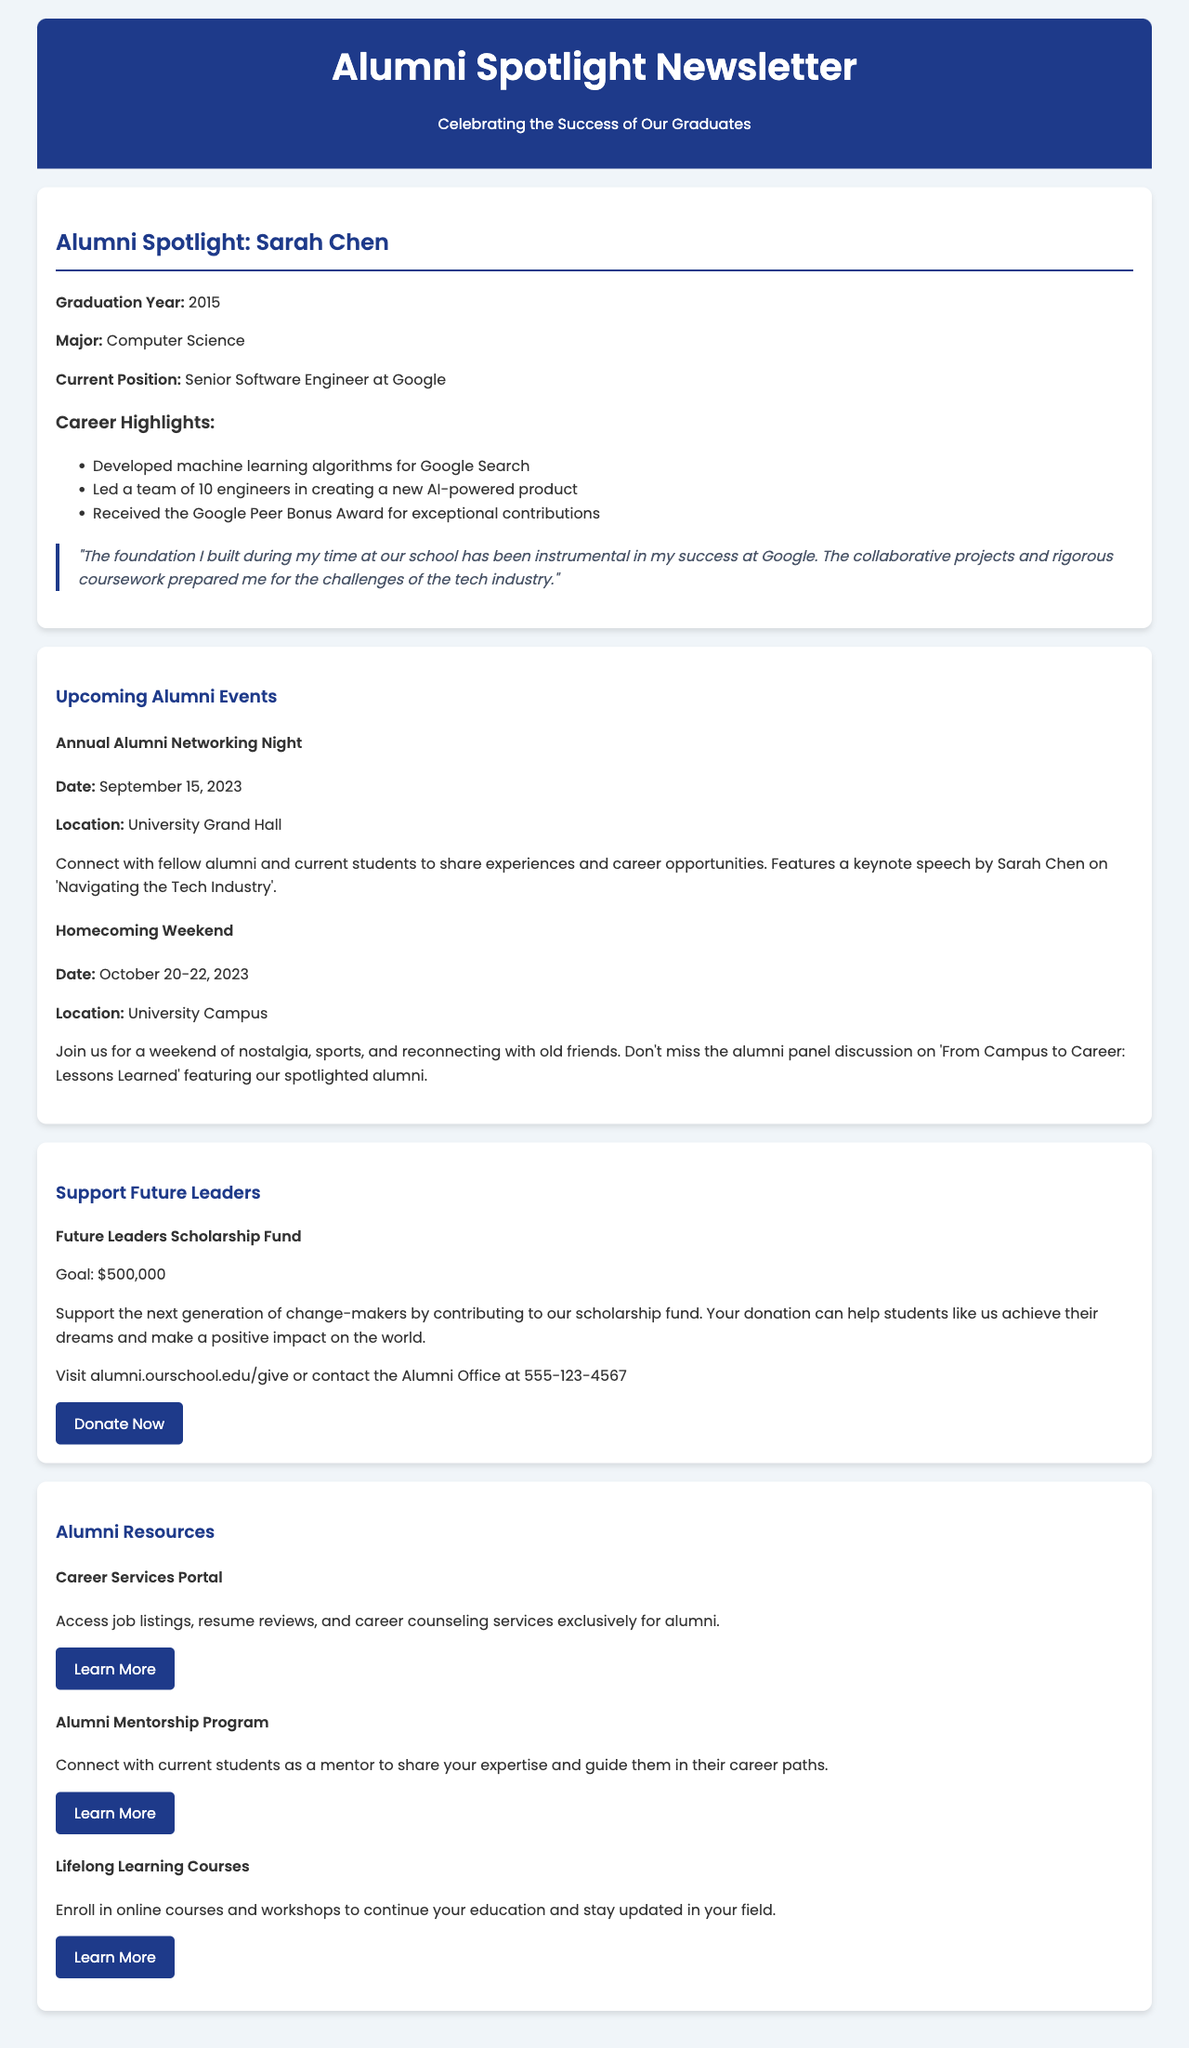What is Sarah Chen's current position? The document explicitly states that Sarah Chen is a Senior Software Engineer at Google.
Answer: Senior Software Engineer at Google What year did Michael Rodriguez graduate? According to the document, Michael Rodriguez graduated in 2012.
Answer: 2012 How much funding did GreenTech Solutions raise? The document mentions that GreenTech Solutions raised $10 million in Series A funding.
Answer: $10 million What is the date of the Annual Alumni Networking Night? The document provides the date as September 15, 2023, for the Annual Alumni Networking Night.
Answer: September 15, 2023 What is the goal amount for the Future Leaders Scholarship Fund? The document indicates that the goal amount for the scholarship fund is $500,000.
Answer: $500,000 Which alumni is featured in the first spotlight? The document features Sarah Chen in the first spotlight section.
Answer: Sarah Chen What program ignited Michael Rodriguez's passion? The document states that the entrepreneurship program at the school ignited his passion for sustainable business.
Answer: Entrepreneurship program What type of projects did Emily Patel work on? Emily Patel worked on humanitarian aid projects in conflict zones across Africa and the Middle East.
Answer: Humanitarian aid projects What is the purpose of the Alumni Mentorship Program? The document describes the Alumni Mentorship Program as a way to connect with current students as a mentor.
Answer: Connect with current students as a mentor What event features a keynote speech by Sarah Chen? The Annual Alumni Networking Night features a keynote speech by Sarah Chen on 'Navigating the Tech Industry'.
Answer: Annual Alumni Networking Night 